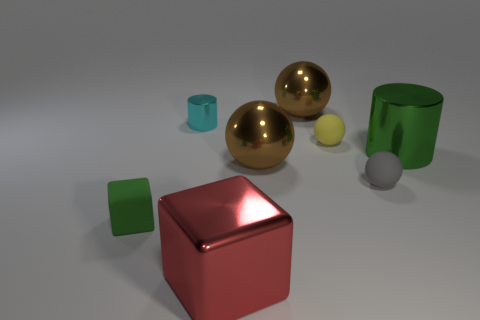How many other things are there of the same color as the small cube?
Give a very brief answer. 1. The red object in front of the big brown ball in front of the tiny cyan object behind the large cylinder is what shape?
Make the answer very short. Cube. How big is the cube that is on the left side of the red shiny object?
Your response must be concise. Small. There is a cube that is in front of the matte block; is it the same size as the small green rubber cube?
Your response must be concise. No. What material is the big ball that is right of the large ball in front of the small yellow matte thing to the right of the large red shiny block?
Give a very brief answer. Metal. There is a green thing that is right of the large red block; what is it made of?
Offer a terse response. Metal. Are there any green things that have the same size as the yellow sphere?
Ensure brevity in your answer.  Yes. Do the shiny object that is to the right of the tiny yellow matte ball and the tiny cube have the same color?
Keep it short and to the point. Yes. How many cyan objects are either tiny objects or big cylinders?
Provide a short and direct response. 1. What number of blocks have the same color as the large metal cylinder?
Your answer should be very brief. 1. 